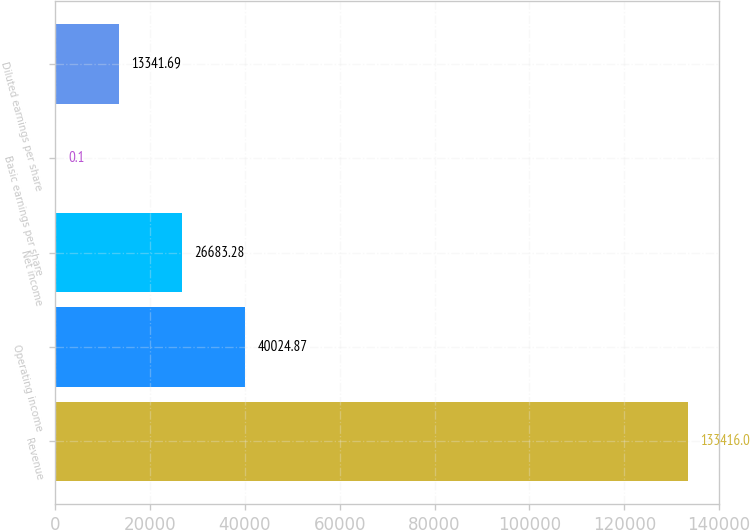<chart> <loc_0><loc_0><loc_500><loc_500><bar_chart><fcel>Revenue<fcel>Operating income<fcel>Net income<fcel>Basic earnings per share<fcel>Diluted earnings per share<nl><fcel>133416<fcel>40024.9<fcel>26683.3<fcel>0.1<fcel>13341.7<nl></chart> 